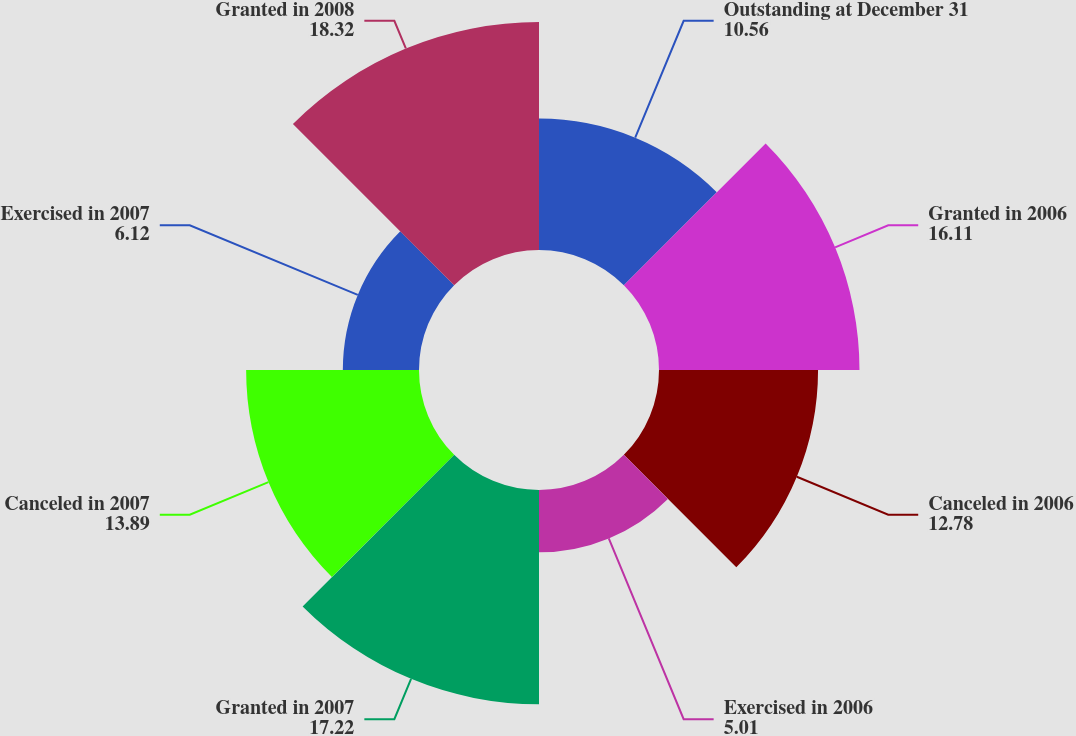<chart> <loc_0><loc_0><loc_500><loc_500><pie_chart><fcel>Outstanding at December 31<fcel>Granted in 2006<fcel>Canceled in 2006<fcel>Exercised in 2006<fcel>Granted in 2007<fcel>Canceled in 2007<fcel>Exercised in 2007<fcel>Granted in 2008<nl><fcel>10.56%<fcel>16.11%<fcel>12.78%<fcel>5.01%<fcel>17.22%<fcel>13.89%<fcel>6.12%<fcel>18.32%<nl></chart> 